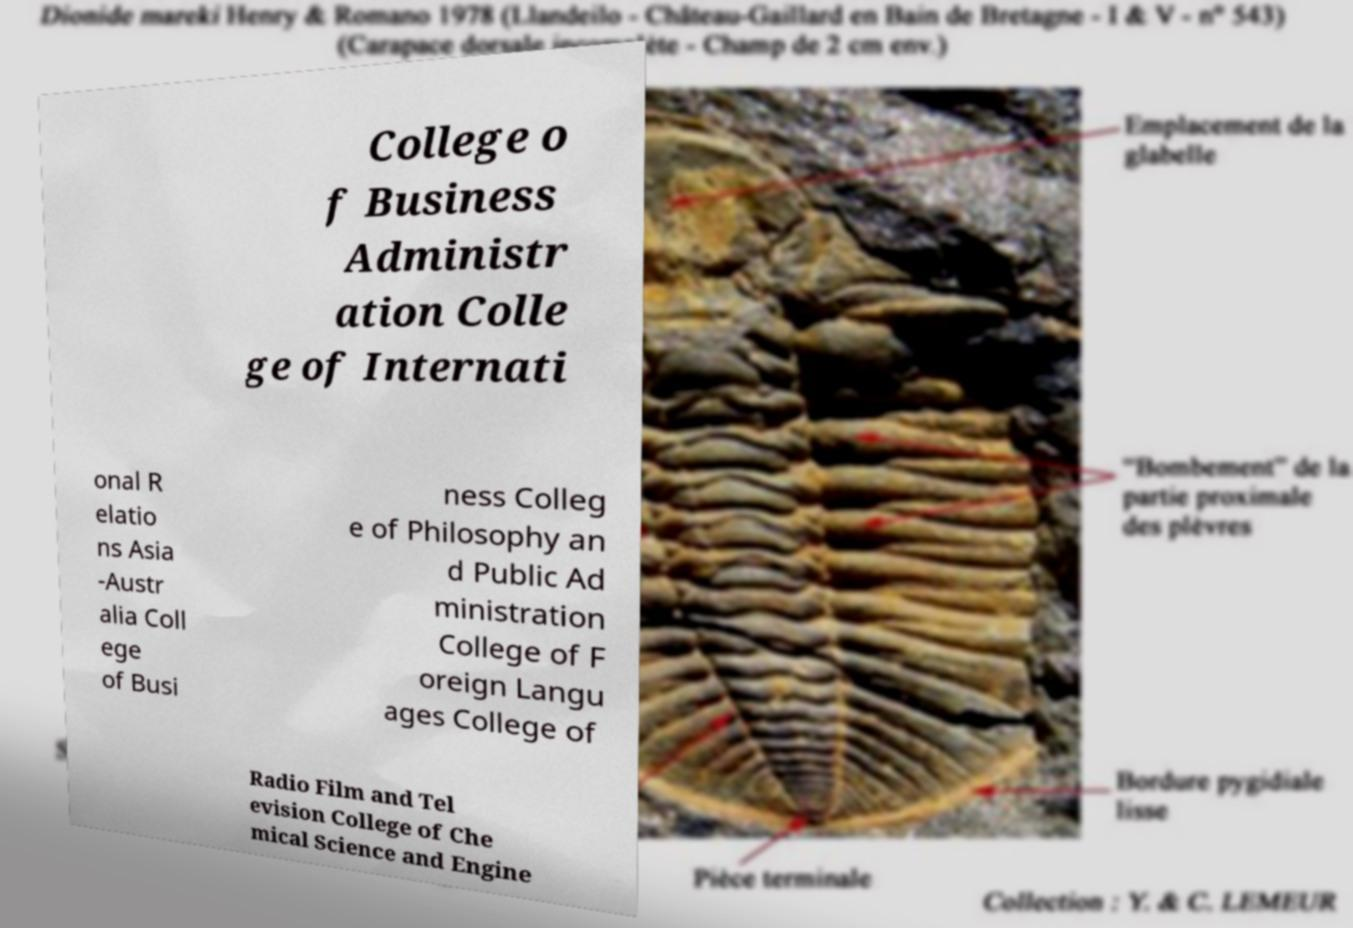Could you assist in decoding the text presented in this image and type it out clearly? College o f Business Administr ation Colle ge of Internati onal R elatio ns Asia -Austr alia Coll ege of Busi ness Colleg e of Philosophy an d Public Ad ministration College of F oreign Langu ages College of Radio Film and Tel evision College of Che mical Science and Engine 